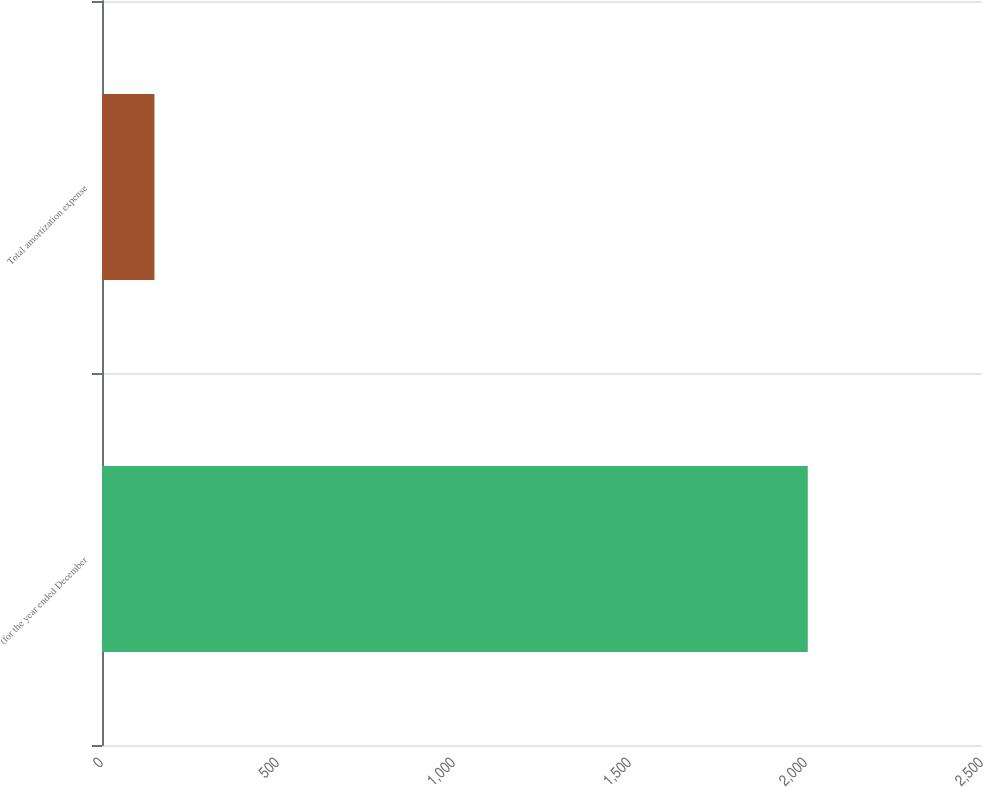<chart> <loc_0><loc_0><loc_500><loc_500><bar_chart><fcel>(for the year ended December<fcel>Total amortization expense<nl><fcel>2005<fcel>149<nl></chart> 